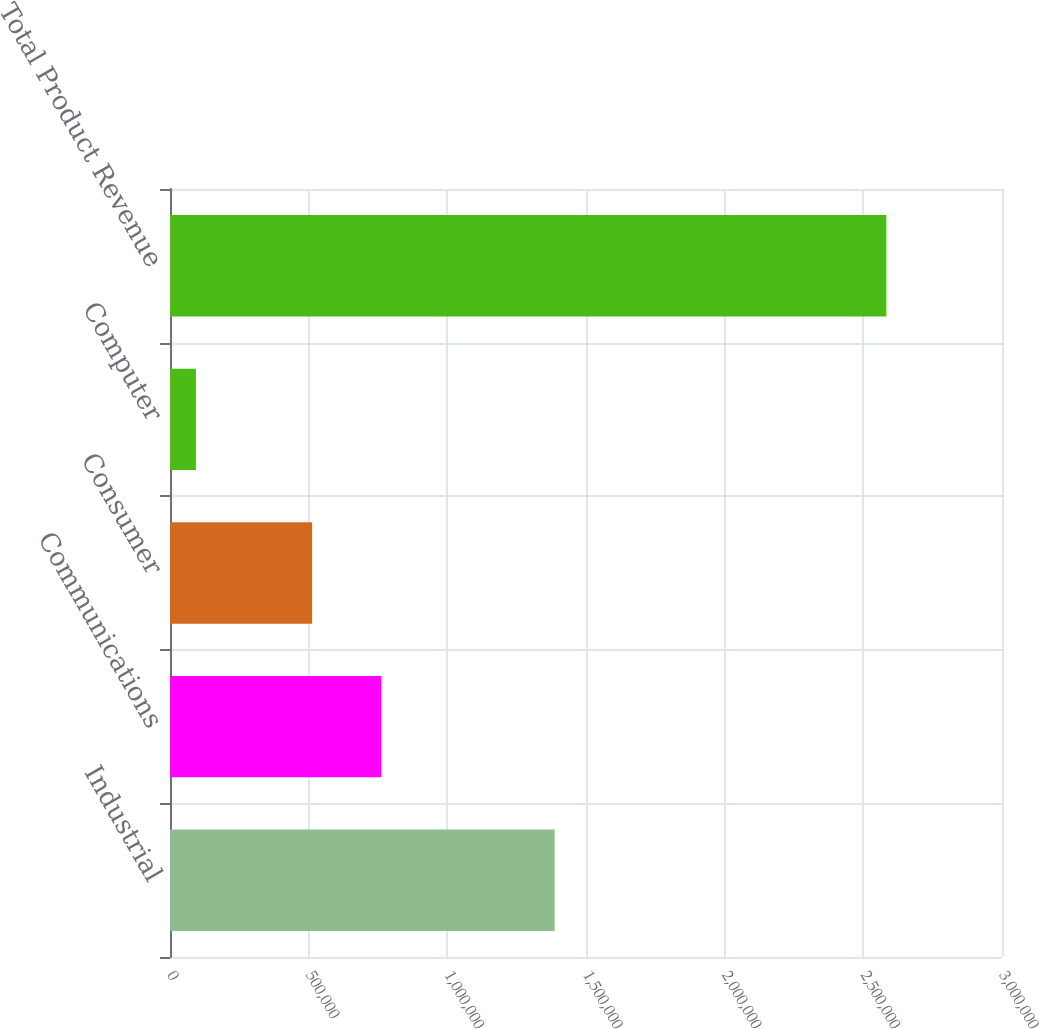<chart> <loc_0><loc_0><loc_500><loc_500><bar_chart><fcel>Industrial<fcel>Communications<fcel>Consumer<fcel>Computer<fcel>Total Product Revenue<nl><fcel>1.38687e+06<fcel>761287<fcel>512339<fcel>93451<fcel>2.58293e+06<nl></chart> 